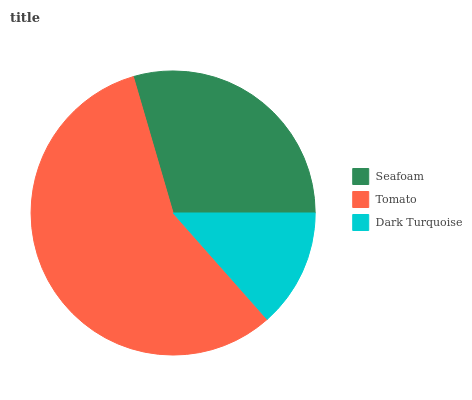Is Dark Turquoise the minimum?
Answer yes or no. Yes. Is Tomato the maximum?
Answer yes or no. Yes. Is Tomato the minimum?
Answer yes or no. No. Is Dark Turquoise the maximum?
Answer yes or no. No. Is Tomato greater than Dark Turquoise?
Answer yes or no. Yes. Is Dark Turquoise less than Tomato?
Answer yes or no. Yes. Is Dark Turquoise greater than Tomato?
Answer yes or no. No. Is Tomato less than Dark Turquoise?
Answer yes or no. No. Is Seafoam the high median?
Answer yes or no. Yes. Is Seafoam the low median?
Answer yes or no. Yes. Is Dark Turquoise the high median?
Answer yes or no. No. Is Dark Turquoise the low median?
Answer yes or no. No. 